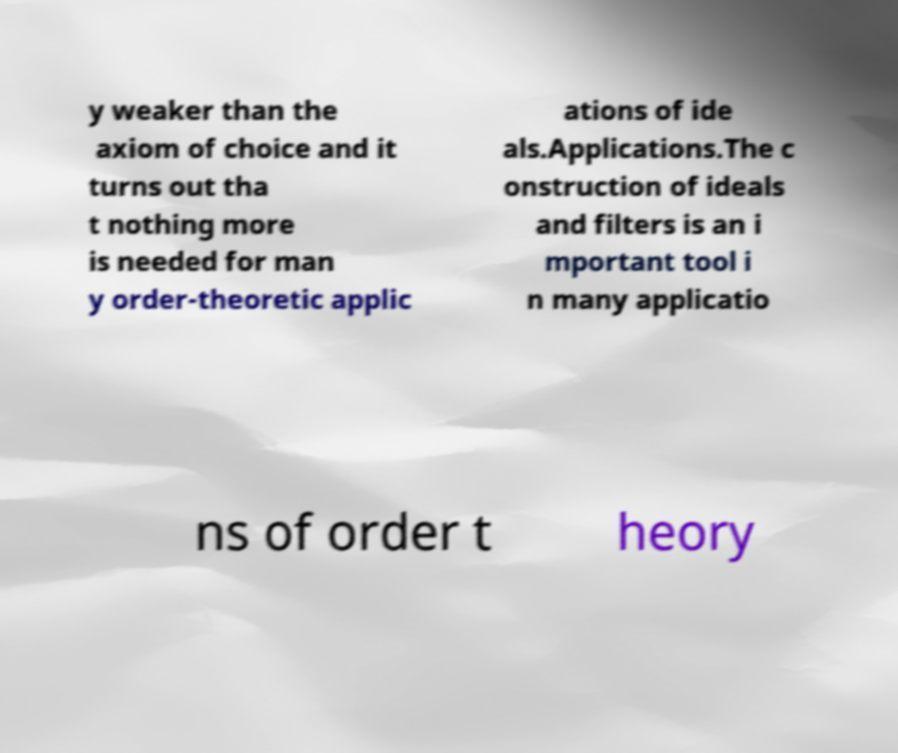For documentation purposes, I need the text within this image transcribed. Could you provide that? y weaker than the axiom of choice and it turns out tha t nothing more is needed for man y order-theoretic applic ations of ide als.Applications.The c onstruction of ideals and filters is an i mportant tool i n many applicatio ns of order t heory 